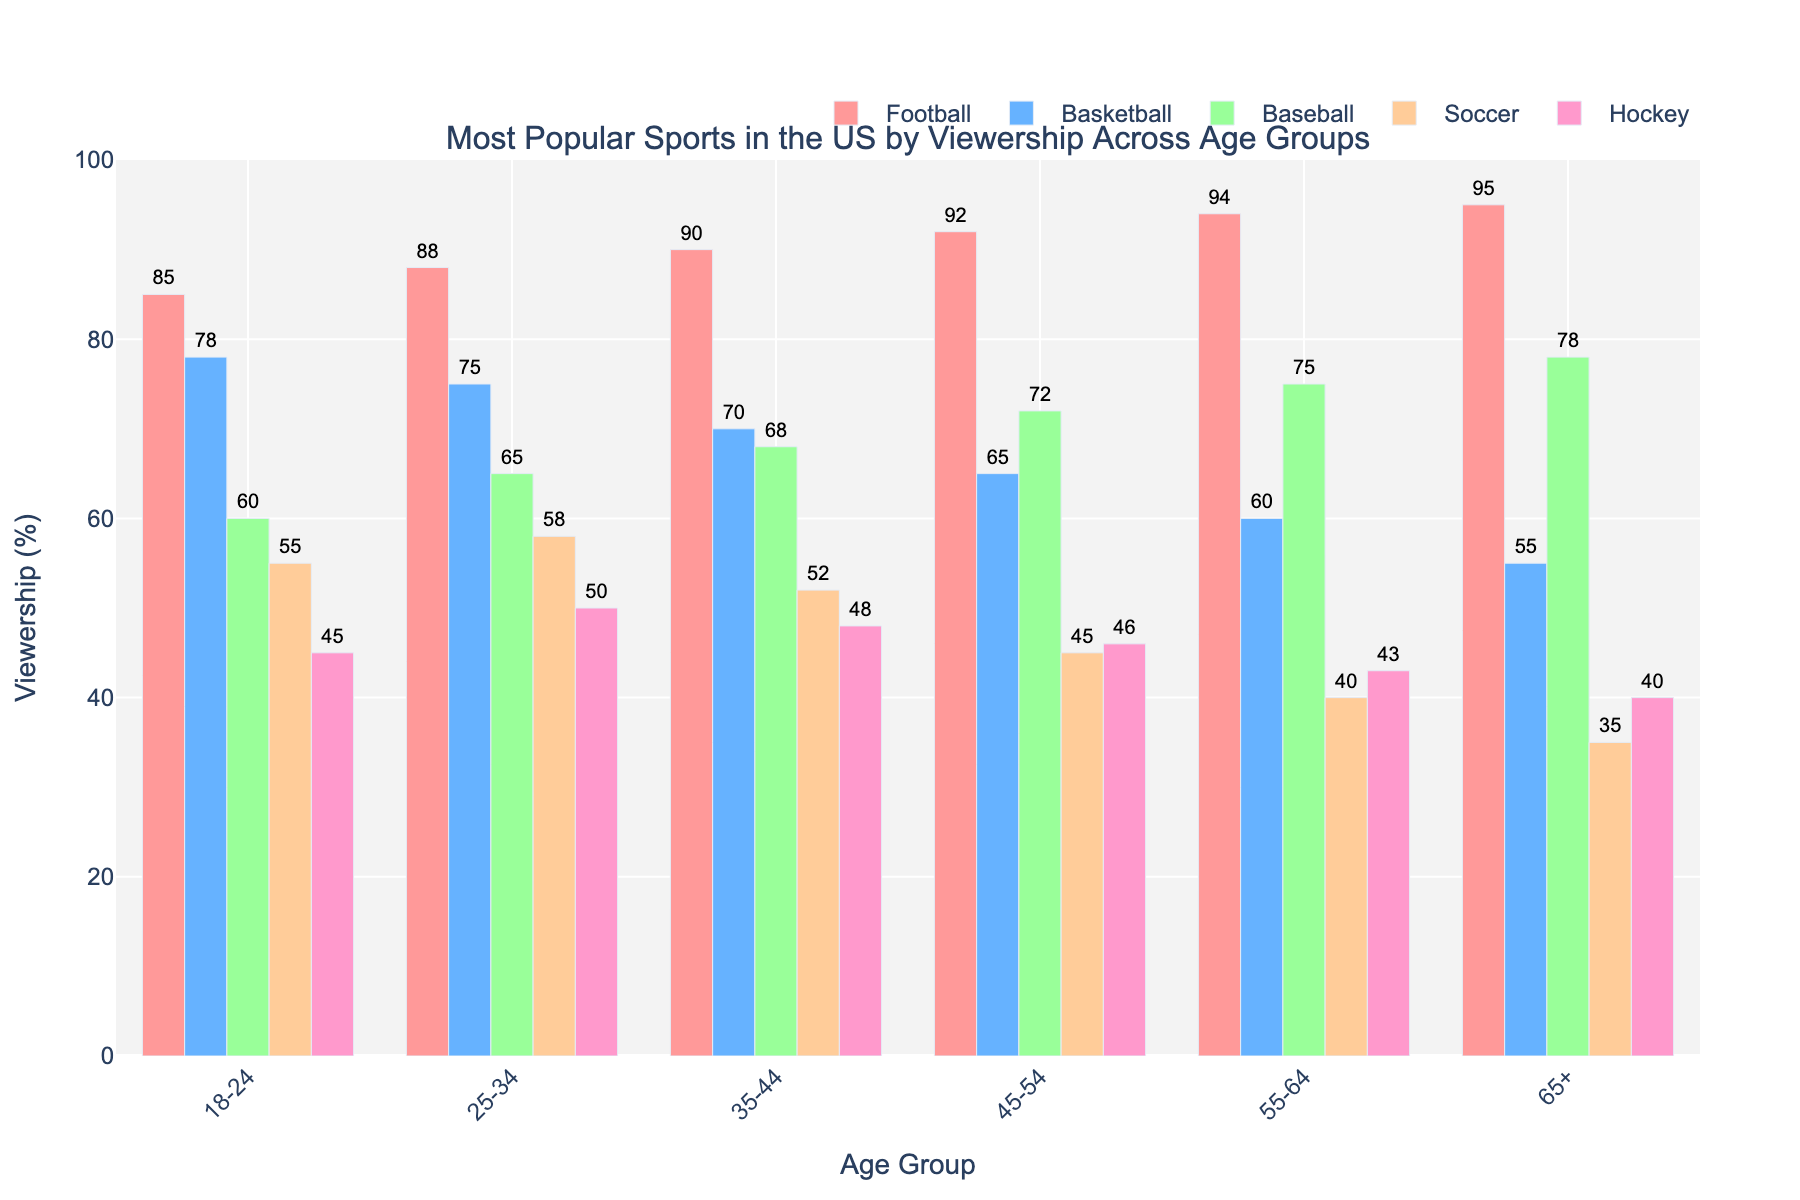What's the viewership of Football in the 35-44 age group? The bar for Football in the 35-44 age group is labeled with the viewership number.
Answer: 90 Between 55-64 and 65+ age groups, which group has higher viewership in Soccer? Compare the heights of the bars for Soccer in the 55-64 and 65+ age groups. The bar for the 55-64 age group is higher.
Answer: 55-64 What is the average viewership of Basketball across all age groups? Add up the Basketball viewership numbers for all age groups (78 + 75 + 70 + 65 + 60 + 55) and divide by the number of age groups (6). Calculation: (78 + 75 + 70 + 65 + 60 + 55) / 6 = 67.17
Answer: 67.17 Which sport has the lowest viewership in the 18-24 age group? Look at the smallest bar in the 18-24 age group.
Answer: Hockey How much higher is Baseball's viewership in the 45-54 age group compared to Soccer in the 18-24 age group? Subtract Soccer's viewership in the 18-24 age group from Baseball's viewership in the 45-54 age group. Calculation: 72 - 55 = 17
Answer: 17 What are the two sports with the closest viewership numbers in the 25-34 age group? Compare the heights of the bars for the 25-34 age group and identify the two bars that are closest in height.
Answer: Football and Basketball In which age group does Soccer have its highest viewership? Find the tallest bar for Soccer across all age groups.
Answer: 25-34 What is the total viewership of Hockey across all age groups? Sum the viewership numbers for Hockey across all age groups (45 + 50 + 48 + 46 + 43 + 40). Calculation: 45 + 50 + 48 + 46 + 43 + 40 = 272
Answer: 272 How does the viewership of Football in the 65+ age group compare to the viewership of Baseball in the same age group? Compare the heights of the bars for Football and Baseball in the 65+ age group. The bar for Football is higher.
Answer: Football > Baseball How much less is the viewership of Soccer compared to Football in the 35-44 age group? Subtract Soccer's viewership from Football's viewership in the 35-44 age group. Calculation: 90 - 52 = 38
Answer: 38 